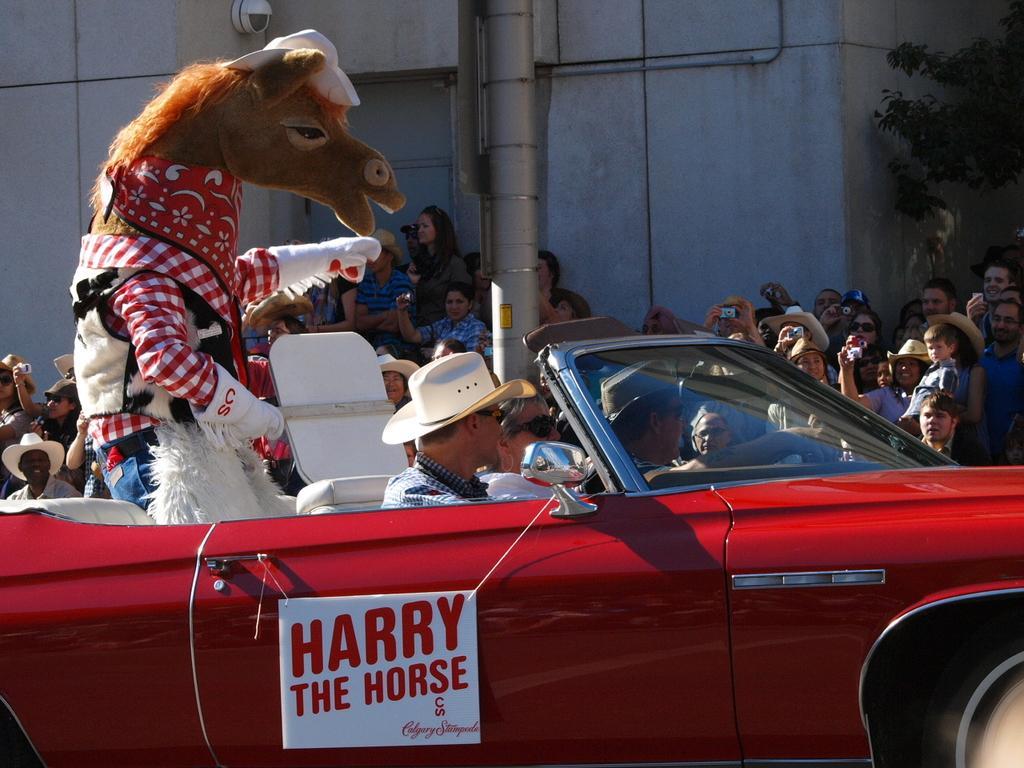In one or two sentences, can you explain what this image depicts? In this image I can see a vehicle which is in red color and I can see few people sitting in the vehicle and I can see a person wearing mask. Background I can see other people standing holding cameras in their hands and I can see trees in green color and the wall is in gray color. 